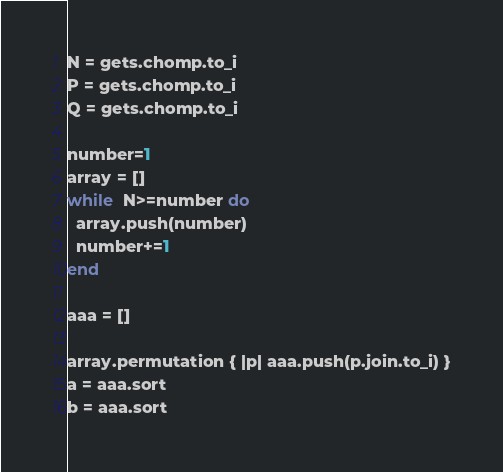Convert code to text. <code><loc_0><loc_0><loc_500><loc_500><_Ruby_>N = gets.chomp.to_i
P = gets.chomp.to_i
Q = gets.chomp.to_i

number=1
array = []
while  N>=number do
  array.push(number)
  number+=1
end

aaa = []

array.permutation { |p| aaa.push(p.join.to_i) }
a = aaa.sort
b = aaa.sort
</code> 